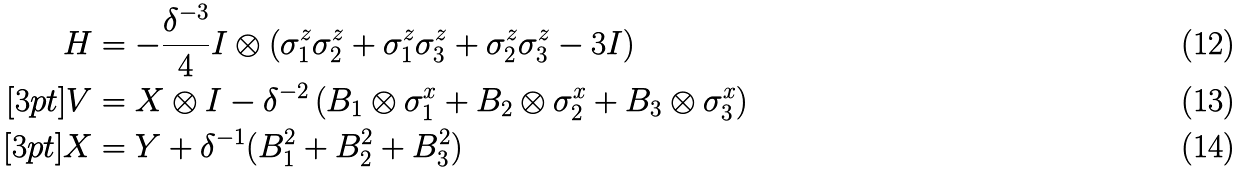Convert formula to latex. <formula><loc_0><loc_0><loc_500><loc_500>H & = - \frac { \delta ^ { - 3 } } { 4 } I \otimes \left ( \sigma ^ { z } _ { 1 } \sigma ^ { z } _ { 2 } + \sigma ^ { z } _ { 1 } \sigma ^ { z } _ { 3 } + \sigma ^ { z } _ { 2 } \sigma ^ { z } _ { 3 } - 3 I \right ) \\ [ 3 p t ] V & = X \otimes I - \delta ^ { - 2 } \left ( B _ { 1 } \otimes \sigma ^ { x } _ { 1 } + B _ { 2 } \otimes \sigma ^ { x } _ { 2 } + B _ { 3 } \otimes \sigma ^ { x } _ { 3 } \right ) \\ [ 3 p t ] X & = Y + \delta ^ { - 1 } ( B _ { 1 } ^ { 2 } + B _ { 2 } ^ { 2 } + B _ { 3 } ^ { 2 } )</formula> 